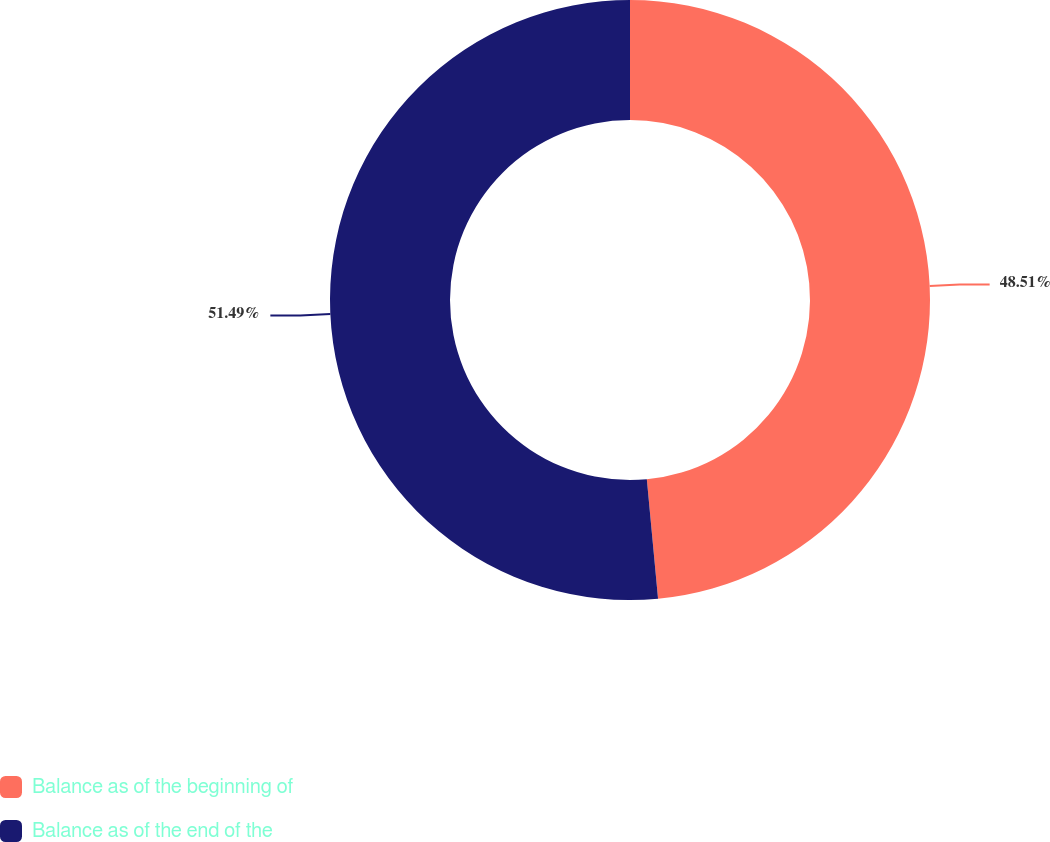Convert chart to OTSL. <chart><loc_0><loc_0><loc_500><loc_500><pie_chart><fcel>Balance as of the beginning of<fcel>Balance as of the end of the<nl><fcel>48.51%<fcel>51.49%<nl></chart> 